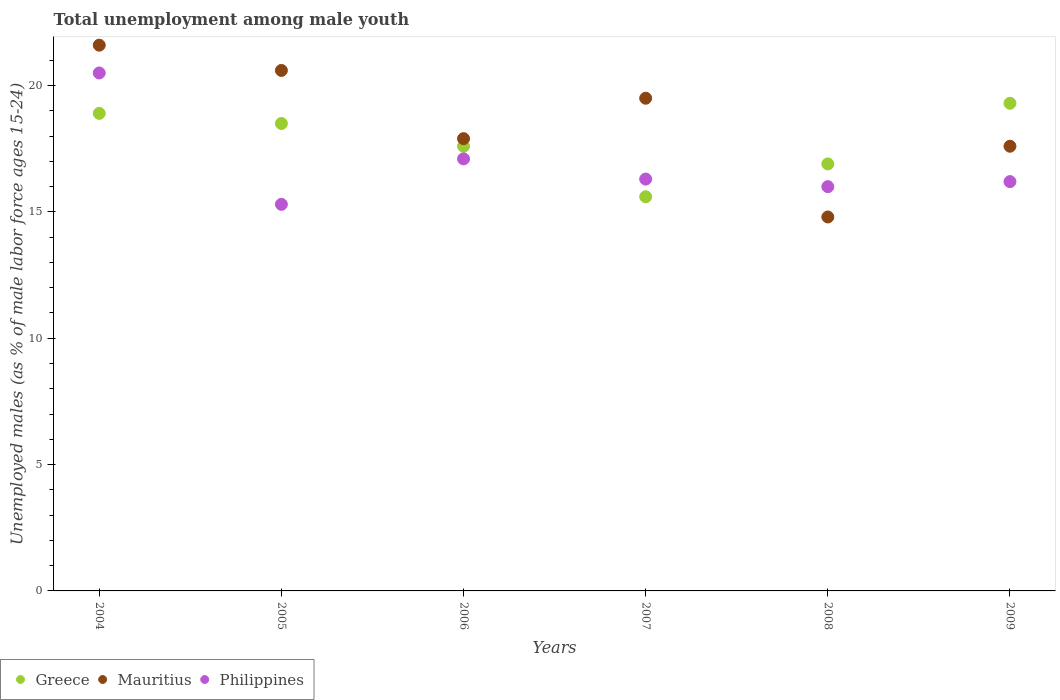How many different coloured dotlines are there?
Provide a succinct answer. 3. Is the number of dotlines equal to the number of legend labels?
Make the answer very short. Yes. What is the percentage of unemployed males in in Greece in 2006?
Ensure brevity in your answer.  17.6. Across all years, what is the maximum percentage of unemployed males in in Mauritius?
Provide a succinct answer. 21.6. Across all years, what is the minimum percentage of unemployed males in in Greece?
Your response must be concise. 15.6. In which year was the percentage of unemployed males in in Greece maximum?
Your answer should be very brief. 2009. In which year was the percentage of unemployed males in in Mauritius minimum?
Keep it short and to the point. 2008. What is the total percentage of unemployed males in in Greece in the graph?
Provide a short and direct response. 106.8. What is the difference between the percentage of unemployed males in in Philippines in 2005 and that in 2008?
Keep it short and to the point. -0.7. What is the difference between the percentage of unemployed males in in Greece in 2008 and the percentage of unemployed males in in Mauritius in 2009?
Offer a very short reply. -0.7. What is the average percentage of unemployed males in in Greece per year?
Ensure brevity in your answer.  17.8. In the year 2004, what is the difference between the percentage of unemployed males in in Mauritius and percentage of unemployed males in in Philippines?
Keep it short and to the point. 1.1. What is the ratio of the percentage of unemployed males in in Philippines in 2006 to that in 2008?
Offer a very short reply. 1.07. Is the percentage of unemployed males in in Greece in 2004 less than that in 2006?
Your answer should be very brief. No. Is the difference between the percentage of unemployed males in in Mauritius in 2008 and 2009 greater than the difference between the percentage of unemployed males in in Philippines in 2008 and 2009?
Keep it short and to the point. No. What is the difference between the highest and the second highest percentage of unemployed males in in Greece?
Your response must be concise. 0.4. What is the difference between the highest and the lowest percentage of unemployed males in in Philippines?
Make the answer very short. 5.2. In how many years, is the percentage of unemployed males in in Greece greater than the average percentage of unemployed males in in Greece taken over all years?
Provide a short and direct response. 3. Is it the case that in every year, the sum of the percentage of unemployed males in in Greece and percentage of unemployed males in in Mauritius  is greater than the percentage of unemployed males in in Philippines?
Ensure brevity in your answer.  Yes. Is the percentage of unemployed males in in Mauritius strictly greater than the percentage of unemployed males in in Greece over the years?
Your answer should be compact. No. Is the percentage of unemployed males in in Philippines strictly less than the percentage of unemployed males in in Mauritius over the years?
Give a very brief answer. No. How many years are there in the graph?
Your response must be concise. 6. Where does the legend appear in the graph?
Keep it short and to the point. Bottom left. How are the legend labels stacked?
Offer a terse response. Horizontal. What is the title of the graph?
Your response must be concise. Total unemployment among male youth. What is the label or title of the Y-axis?
Provide a succinct answer. Unemployed males (as % of male labor force ages 15-24). What is the Unemployed males (as % of male labor force ages 15-24) of Greece in 2004?
Offer a terse response. 18.9. What is the Unemployed males (as % of male labor force ages 15-24) of Mauritius in 2004?
Give a very brief answer. 21.6. What is the Unemployed males (as % of male labor force ages 15-24) in Philippines in 2004?
Provide a succinct answer. 20.5. What is the Unemployed males (as % of male labor force ages 15-24) of Mauritius in 2005?
Keep it short and to the point. 20.6. What is the Unemployed males (as % of male labor force ages 15-24) in Philippines in 2005?
Offer a very short reply. 15.3. What is the Unemployed males (as % of male labor force ages 15-24) of Greece in 2006?
Offer a very short reply. 17.6. What is the Unemployed males (as % of male labor force ages 15-24) in Mauritius in 2006?
Ensure brevity in your answer.  17.9. What is the Unemployed males (as % of male labor force ages 15-24) of Philippines in 2006?
Your answer should be very brief. 17.1. What is the Unemployed males (as % of male labor force ages 15-24) in Greece in 2007?
Keep it short and to the point. 15.6. What is the Unemployed males (as % of male labor force ages 15-24) of Mauritius in 2007?
Your response must be concise. 19.5. What is the Unemployed males (as % of male labor force ages 15-24) of Philippines in 2007?
Ensure brevity in your answer.  16.3. What is the Unemployed males (as % of male labor force ages 15-24) in Greece in 2008?
Ensure brevity in your answer.  16.9. What is the Unemployed males (as % of male labor force ages 15-24) of Mauritius in 2008?
Offer a very short reply. 14.8. What is the Unemployed males (as % of male labor force ages 15-24) in Greece in 2009?
Your answer should be very brief. 19.3. What is the Unemployed males (as % of male labor force ages 15-24) in Mauritius in 2009?
Keep it short and to the point. 17.6. What is the Unemployed males (as % of male labor force ages 15-24) in Philippines in 2009?
Your answer should be very brief. 16.2. Across all years, what is the maximum Unemployed males (as % of male labor force ages 15-24) of Greece?
Keep it short and to the point. 19.3. Across all years, what is the maximum Unemployed males (as % of male labor force ages 15-24) in Mauritius?
Ensure brevity in your answer.  21.6. Across all years, what is the maximum Unemployed males (as % of male labor force ages 15-24) of Philippines?
Provide a succinct answer. 20.5. Across all years, what is the minimum Unemployed males (as % of male labor force ages 15-24) of Greece?
Ensure brevity in your answer.  15.6. Across all years, what is the minimum Unemployed males (as % of male labor force ages 15-24) of Mauritius?
Give a very brief answer. 14.8. Across all years, what is the minimum Unemployed males (as % of male labor force ages 15-24) in Philippines?
Your answer should be very brief. 15.3. What is the total Unemployed males (as % of male labor force ages 15-24) of Greece in the graph?
Give a very brief answer. 106.8. What is the total Unemployed males (as % of male labor force ages 15-24) in Mauritius in the graph?
Give a very brief answer. 112. What is the total Unemployed males (as % of male labor force ages 15-24) in Philippines in the graph?
Offer a terse response. 101.4. What is the difference between the Unemployed males (as % of male labor force ages 15-24) in Philippines in 2004 and that in 2006?
Keep it short and to the point. 3.4. What is the difference between the Unemployed males (as % of male labor force ages 15-24) of Greece in 2004 and that in 2007?
Your answer should be very brief. 3.3. What is the difference between the Unemployed males (as % of male labor force ages 15-24) of Philippines in 2004 and that in 2007?
Provide a short and direct response. 4.2. What is the difference between the Unemployed males (as % of male labor force ages 15-24) in Greece in 2004 and that in 2008?
Your answer should be very brief. 2. What is the difference between the Unemployed males (as % of male labor force ages 15-24) of Philippines in 2004 and that in 2008?
Offer a terse response. 4.5. What is the difference between the Unemployed males (as % of male labor force ages 15-24) of Mauritius in 2004 and that in 2009?
Provide a succinct answer. 4. What is the difference between the Unemployed males (as % of male labor force ages 15-24) in Philippines in 2004 and that in 2009?
Your answer should be compact. 4.3. What is the difference between the Unemployed males (as % of male labor force ages 15-24) in Greece in 2005 and that in 2007?
Your answer should be very brief. 2.9. What is the difference between the Unemployed males (as % of male labor force ages 15-24) in Mauritius in 2005 and that in 2008?
Offer a terse response. 5.8. What is the difference between the Unemployed males (as % of male labor force ages 15-24) in Philippines in 2005 and that in 2008?
Provide a short and direct response. -0.7. What is the difference between the Unemployed males (as % of male labor force ages 15-24) in Mauritius in 2006 and that in 2007?
Offer a terse response. -1.6. What is the difference between the Unemployed males (as % of male labor force ages 15-24) of Philippines in 2006 and that in 2007?
Make the answer very short. 0.8. What is the difference between the Unemployed males (as % of male labor force ages 15-24) in Greece in 2006 and that in 2008?
Offer a terse response. 0.7. What is the difference between the Unemployed males (as % of male labor force ages 15-24) in Mauritius in 2006 and that in 2008?
Make the answer very short. 3.1. What is the difference between the Unemployed males (as % of male labor force ages 15-24) of Philippines in 2006 and that in 2008?
Your answer should be compact. 1.1. What is the difference between the Unemployed males (as % of male labor force ages 15-24) of Philippines in 2006 and that in 2009?
Offer a very short reply. 0.9. What is the difference between the Unemployed males (as % of male labor force ages 15-24) in Mauritius in 2007 and that in 2008?
Give a very brief answer. 4.7. What is the difference between the Unemployed males (as % of male labor force ages 15-24) in Philippines in 2007 and that in 2008?
Your answer should be very brief. 0.3. What is the difference between the Unemployed males (as % of male labor force ages 15-24) of Philippines in 2008 and that in 2009?
Provide a succinct answer. -0.2. What is the difference between the Unemployed males (as % of male labor force ages 15-24) of Mauritius in 2004 and the Unemployed males (as % of male labor force ages 15-24) of Philippines in 2005?
Provide a succinct answer. 6.3. What is the difference between the Unemployed males (as % of male labor force ages 15-24) of Greece in 2004 and the Unemployed males (as % of male labor force ages 15-24) of Philippines in 2006?
Provide a succinct answer. 1.8. What is the difference between the Unemployed males (as % of male labor force ages 15-24) in Mauritius in 2004 and the Unemployed males (as % of male labor force ages 15-24) in Philippines in 2006?
Give a very brief answer. 4.5. What is the difference between the Unemployed males (as % of male labor force ages 15-24) in Mauritius in 2004 and the Unemployed males (as % of male labor force ages 15-24) in Philippines in 2007?
Offer a terse response. 5.3. What is the difference between the Unemployed males (as % of male labor force ages 15-24) in Mauritius in 2004 and the Unemployed males (as % of male labor force ages 15-24) in Philippines in 2008?
Ensure brevity in your answer.  5.6. What is the difference between the Unemployed males (as % of male labor force ages 15-24) of Greece in 2004 and the Unemployed males (as % of male labor force ages 15-24) of Mauritius in 2009?
Keep it short and to the point. 1.3. What is the difference between the Unemployed males (as % of male labor force ages 15-24) in Mauritius in 2004 and the Unemployed males (as % of male labor force ages 15-24) in Philippines in 2009?
Offer a terse response. 5.4. What is the difference between the Unemployed males (as % of male labor force ages 15-24) in Greece in 2005 and the Unemployed males (as % of male labor force ages 15-24) in Mauritius in 2006?
Your answer should be very brief. 0.6. What is the difference between the Unemployed males (as % of male labor force ages 15-24) of Mauritius in 2005 and the Unemployed males (as % of male labor force ages 15-24) of Philippines in 2006?
Offer a very short reply. 3.5. What is the difference between the Unemployed males (as % of male labor force ages 15-24) of Greece in 2005 and the Unemployed males (as % of male labor force ages 15-24) of Mauritius in 2008?
Your response must be concise. 3.7. What is the difference between the Unemployed males (as % of male labor force ages 15-24) in Greece in 2005 and the Unemployed males (as % of male labor force ages 15-24) in Philippines in 2008?
Provide a succinct answer. 2.5. What is the difference between the Unemployed males (as % of male labor force ages 15-24) of Mauritius in 2005 and the Unemployed males (as % of male labor force ages 15-24) of Philippines in 2008?
Keep it short and to the point. 4.6. What is the difference between the Unemployed males (as % of male labor force ages 15-24) in Greece in 2005 and the Unemployed males (as % of male labor force ages 15-24) in Mauritius in 2009?
Your response must be concise. 0.9. What is the difference between the Unemployed males (as % of male labor force ages 15-24) of Greece in 2005 and the Unemployed males (as % of male labor force ages 15-24) of Philippines in 2009?
Provide a short and direct response. 2.3. What is the difference between the Unemployed males (as % of male labor force ages 15-24) in Mauritius in 2006 and the Unemployed males (as % of male labor force ages 15-24) in Philippines in 2007?
Offer a terse response. 1.6. What is the difference between the Unemployed males (as % of male labor force ages 15-24) of Mauritius in 2006 and the Unemployed males (as % of male labor force ages 15-24) of Philippines in 2008?
Keep it short and to the point. 1.9. What is the difference between the Unemployed males (as % of male labor force ages 15-24) of Greece in 2006 and the Unemployed males (as % of male labor force ages 15-24) of Mauritius in 2009?
Provide a short and direct response. 0. What is the difference between the Unemployed males (as % of male labor force ages 15-24) in Greece in 2007 and the Unemployed males (as % of male labor force ages 15-24) in Mauritius in 2008?
Provide a short and direct response. 0.8. What is the difference between the Unemployed males (as % of male labor force ages 15-24) in Mauritius in 2007 and the Unemployed males (as % of male labor force ages 15-24) in Philippines in 2008?
Provide a short and direct response. 3.5. What is the difference between the Unemployed males (as % of male labor force ages 15-24) of Greece in 2007 and the Unemployed males (as % of male labor force ages 15-24) of Mauritius in 2009?
Your answer should be very brief. -2. What is the difference between the Unemployed males (as % of male labor force ages 15-24) of Greece in 2007 and the Unemployed males (as % of male labor force ages 15-24) of Philippines in 2009?
Offer a terse response. -0.6. What is the difference between the Unemployed males (as % of male labor force ages 15-24) in Mauritius in 2007 and the Unemployed males (as % of male labor force ages 15-24) in Philippines in 2009?
Your answer should be compact. 3.3. What is the difference between the Unemployed males (as % of male labor force ages 15-24) in Greece in 2008 and the Unemployed males (as % of male labor force ages 15-24) in Mauritius in 2009?
Ensure brevity in your answer.  -0.7. What is the difference between the Unemployed males (as % of male labor force ages 15-24) of Greece in 2008 and the Unemployed males (as % of male labor force ages 15-24) of Philippines in 2009?
Your response must be concise. 0.7. What is the average Unemployed males (as % of male labor force ages 15-24) in Mauritius per year?
Give a very brief answer. 18.67. In the year 2004, what is the difference between the Unemployed males (as % of male labor force ages 15-24) in Greece and Unemployed males (as % of male labor force ages 15-24) in Philippines?
Your answer should be compact. -1.6. In the year 2004, what is the difference between the Unemployed males (as % of male labor force ages 15-24) in Mauritius and Unemployed males (as % of male labor force ages 15-24) in Philippines?
Your answer should be compact. 1.1. In the year 2005, what is the difference between the Unemployed males (as % of male labor force ages 15-24) of Greece and Unemployed males (as % of male labor force ages 15-24) of Mauritius?
Make the answer very short. -2.1. In the year 2005, what is the difference between the Unemployed males (as % of male labor force ages 15-24) of Greece and Unemployed males (as % of male labor force ages 15-24) of Philippines?
Your response must be concise. 3.2. In the year 2007, what is the difference between the Unemployed males (as % of male labor force ages 15-24) in Mauritius and Unemployed males (as % of male labor force ages 15-24) in Philippines?
Keep it short and to the point. 3.2. In the year 2008, what is the difference between the Unemployed males (as % of male labor force ages 15-24) in Greece and Unemployed males (as % of male labor force ages 15-24) in Mauritius?
Offer a terse response. 2.1. In the year 2008, what is the difference between the Unemployed males (as % of male labor force ages 15-24) of Greece and Unemployed males (as % of male labor force ages 15-24) of Philippines?
Offer a terse response. 0.9. In the year 2009, what is the difference between the Unemployed males (as % of male labor force ages 15-24) in Greece and Unemployed males (as % of male labor force ages 15-24) in Mauritius?
Your response must be concise. 1.7. In the year 2009, what is the difference between the Unemployed males (as % of male labor force ages 15-24) in Greece and Unemployed males (as % of male labor force ages 15-24) in Philippines?
Your response must be concise. 3.1. What is the ratio of the Unemployed males (as % of male labor force ages 15-24) in Greece in 2004 to that in 2005?
Make the answer very short. 1.02. What is the ratio of the Unemployed males (as % of male labor force ages 15-24) in Mauritius in 2004 to that in 2005?
Your answer should be compact. 1.05. What is the ratio of the Unemployed males (as % of male labor force ages 15-24) of Philippines in 2004 to that in 2005?
Offer a terse response. 1.34. What is the ratio of the Unemployed males (as % of male labor force ages 15-24) in Greece in 2004 to that in 2006?
Your answer should be compact. 1.07. What is the ratio of the Unemployed males (as % of male labor force ages 15-24) of Mauritius in 2004 to that in 2006?
Your answer should be very brief. 1.21. What is the ratio of the Unemployed males (as % of male labor force ages 15-24) of Philippines in 2004 to that in 2006?
Provide a short and direct response. 1.2. What is the ratio of the Unemployed males (as % of male labor force ages 15-24) in Greece in 2004 to that in 2007?
Give a very brief answer. 1.21. What is the ratio of the Unemployed males (as % of male labor force ages 15-24) of Mauritius in 2004 to that in 2007?
Ensure brevity in your answer.  1.11. What is the ratio of the Unemployed males (as % of male labor force ages 15-24) in Philippines in 2004 to that in 2007?
Provide a short and direct response. 1.26. What is the ratio of the Unemployed males (as % of male labor force ages 15-24) of Greece in 2004 to that in 2008?
Offer a very short reply. 1.12. What is the ratio of the Unemployed males (as % of male labor force ages 15-24) of Mauritius in 2004 to that in 2008?
Your answer should be compact. 1.46. What is the ratio of the Unemployed males (as % of male labor force ages 15-24) of Philippines in 2004 to that in 2008?
Provide a short and direct response. 1.28. What is the ratio of the Unemployed males (as % of male labor force ages 15-24) of Greece in 2004 to that in 2009?
Provide a short and direct response. 0.98. What is the ratio of the Unemployed males (as % of male labor force ages 15-24) of Mauritius in 2004 to that in 2009?
Offer a terse response. 1.23. What is the ratio of the Unemployed males (as % of male labor force ages 15-24) of Philippines in 2004 to that in 2009?
Offer a very short reply. 1.27. What is the ratio of the Unemployed males (as % of male labor force ages 15-24) in Greece in 2005 to that in 2006?
Your answer should be very brief. 1.05. What is the ratio of the Unemployed males (as % of male labor force ages 15-24) of Mauritius in 2005 to that in 2006?
Give a very brief answer. 1.15. What is the ratio of the Unemployed males (as % of male labor force ages 15-24) of Philippines in 2005 to that in 2006?
Make the answer very short. 0.89. What is the ratio of the Unemployed males (as % of male labor force ages 15-24) in Greece in 2005 to that in 2007?
Provide a short and direct response. 1.19. What is the ratio of the Unemployed males (as % of male labor force ages 15-24) in Mauritius in 2005 to that in 2007?
Give a very brief answer. 1.06. What is the ratio of the Unemployed males (as % of male labor force ages 15-24) in Philippines in 2005 to that in 2007?
Your answer should be very brief. 0.94. What is the ratio of the Unemployed males (as % of male labor force ages 15-24) of Greece in 2005 to that in 2008?
Provide a short and direct response. 1.09. What is the ratio of the Unemployed males (as % of male labor force ages 15-24) of Mauritius in 2005 to that in 2008?
Keep it short and to the point. 1.39. What is the ratio of the Unemployed males (as % of male labor force ages 15-24) in Philippines in 2005 to that in 2008?
Provide a short and direct response. 0.96. What is the ratio of the Unemployed males (as % of male labor force ages 15-24) in Greece in 2005 to that in 2009?
Provide a succinct answer. 0.96. What is the ratio of the Unemployed males (as % of male labor force ages 15-24) of Mauritius in 2005 to that in 2009?
Your answer should be very brief. 1.17. What is the ratio of the Unemployed males (as % of male labor force ages 15-24) of Philippines in 2005 to that in 2009?
Make the answer very short. 0.94. What is the ratio of the Unemployed males (as % of male labor force ages 15-24) in Greece in 2006 to that in 2007?
Offer a terse response. 1.13. What is the ratio of the Unemployed males (as % of male labor force ages 15-24) in Mauritius in 2006 to that in 2007?
Your response must be concise. 0.92. What is the ratio of the Unemployed males (as % of male labor force ages 15-24) of Philippines in 2006 to that in 2007?
Make the answer very short. 1.05. What is the ratio of the Unemployed males (as % of male labor force ages 15-24) in Greece in 2006 to that in 2008?
Your answer should be compact. 1.04. What is the ratio of the Unemployed males (as % of male labor force ages 15-24) of Mauritius in 2006 to that in 2008?
Make the answer very short. 1.21. What is the ratio of the Unemployed males (as % of male labor force ages 15-24) of Philippines in 2006 to that in 2008?
Keep it short and to the point. 1.07. What is the ratio of the Unemployed males (as % of male labor force ages 15-24) of Greece in 2006 to that in 2009?
Your answer should be very brief. 0.91. What is the ratio of the Unemployed males (as % of male labor force ages 15-24) of Mauritius in 2006 to that in 2009?
Provide a short and direct response. 1.02. What is the ratio of the Unemployed males (as % of male labor force ages 15-24) of Philippines in 2006 to that in 2009?
Give a very brief answer. 1.06. What is the ratio of the Unemployed males (as % of male labor force ages 15-24) in Greece in 2007 to that in 2008?
Give a very brief answer. 0.92. What is the ratio of the Unemployed males (as % of male labor force ages 15-24) in Mauritius in 2007 to that in 2008?
Offer a terse response. 1.32. What is the ratio of the Unemployed males (as % of male labor force ages 15-24) of Philippines in 2007 to that in 2008?
Provide a succinct answer. 1.02. What is the ratio of the Unemployed males (as % of male labor force ages 15-24) of Greece in 2007 to that in 2009?
Your response must be concise. 0.81. What is the ratio of the Unemployed males (as % of male labor force ages 15-24) of Mauritius in 2007 to that in 2009?
Offer a very short reply. 1.11. What is the ratio of the Unemployed males (as % of male labor force ages 15-24) in Philippines in 2007 to that in 2009?
Make the answer very short. 1.01. What is the ratio of the Unemployed males (as % of male labor force ages 15-24) of Greece in 2008 to that in 2009?
Your answer should be very brief. 0.88. What is the ratio of the Unemployed males (as % of male labor force ages 15-24) of Mauritius in 2008 to that in 2009?
Give a very brief answer. 0.84. What is the difference between the highest and the second highest Unemployed males (as % of male labor force ages 15-24) of Mauritius?
Provide a short and direct response. 1. What is the difference between the highest and the lowest Unemployed males (as % of male labor force ages 15-24) of Philippines?
Your answer should be very brief. 5.2. 